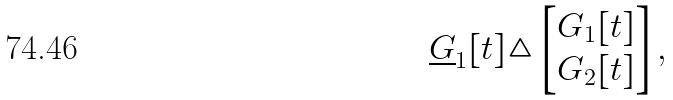<formula> <loc_0><loc_0><loc_500><loc_500>\underline { G } _ { 1 } [ t ] \triangle & \begin{bmatrix} G _ { 1 } [ t ] \\ G _ { 2 } [ t ] \end{bmatrix} ,</formula> 